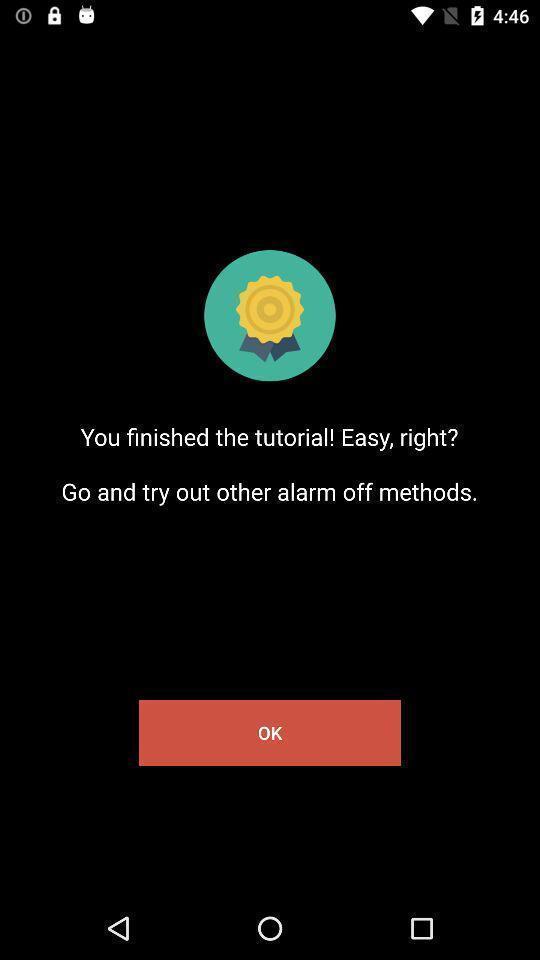What details can you identify in this image? Page showing information. 